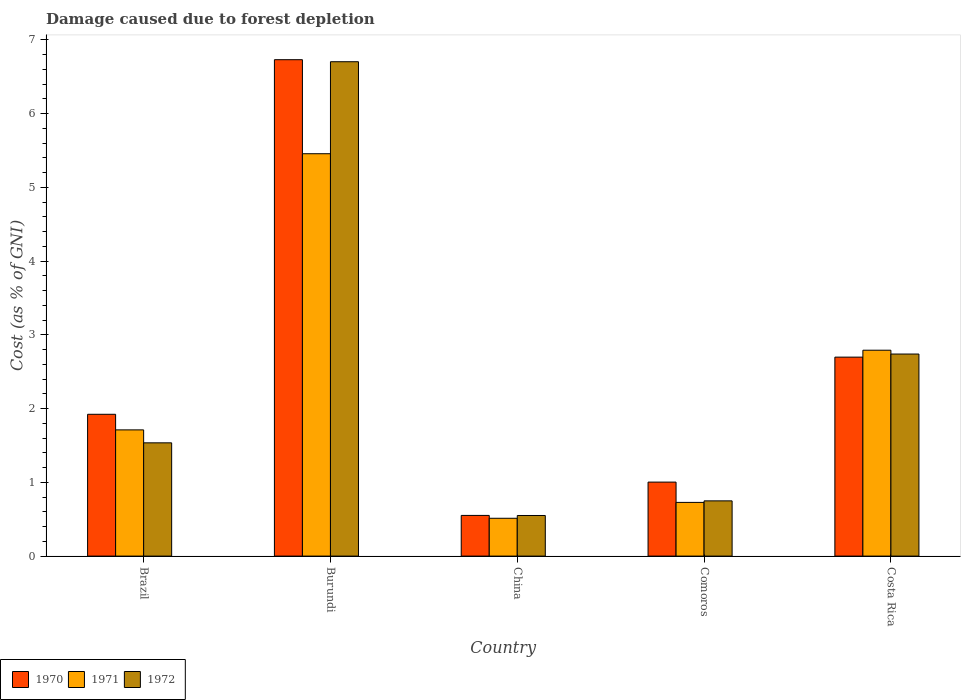How many different coloured bars are there?
Offer a very short reply. 3. Are the number of bars per tick equal to the number of legend labels?
Provide a short and direct response. Yes. Are the number of bars on each tick of the X-axis equal?
Provide a short and direct response. Yes. How many bars are there on the 1st tick from the left?
Make the answer very short. 3. What is the cost of damage caused due to forest depletion in 1972 in Costa Rica?
Your answer should be very brief. 2.74. Across all countries, what is the maximum cost of damage caused due to forest depletion in 1970?
Your answer should be compact. 6.73. Across all countries, what is the minimum cost of damage caused due to forest depletion in 1971?
Your answer should be very brief. 0.51. In which country was the cost of damage caused due to forest depletion in 1971 maximum?
Provide a short and direct response. Burundi. In which country was the cost of damage caused due to forest depletion in 1970 minimum?
Provide a short and direct response. China. What is the total cost of damage caused due to forest depletion in 1971 in the graph?
Your answer should be compact. 11.2. What is the difference between the cost of damage caused due to forest depletion in 1971 in Brazil and that in Burundi?
Keep it short and to the point. -3.75. What is the difference between the cost of damage caused due to forest depletion in 1972 in Burundi and the cost of damage caused due to forest depletion in 1970 in Costa Rica?
Your answer should be very brief. 4.01. What is the average cost of damage caused due to forest depletion in 1970 per country?
Make the answer very short. 2.58. What is the difference between the cost of damage caused due to forest depletion of/in 1970 and cost of damage caused due to forest depletion of/in 1972 in Comoros?
Make the answer very short. 0.25. What is the ratio of the cost of damage caused due to forest depletion in 1971 in Burundi to that in Costa Rica?
Offer a terse response. 1.95. Is the difference between the cost of damage caused due to forest depletion in 1970 in Burundi and Costa Rica greater than the difference between the cost of damage caused due to forest depletion in 1972 in Burundi and Costa Rica?
Provide a short and direct response. Yes. What is the difference between the highest and the second highest cost of damage caused due to forest depletion in 1972?
Your answer should be very brief. -1.2. What is the difference between the highest and the lowest cost of damage caused due to forest depletion in 1972?
Provide a succinct answer. 6.15. Is the sum of the cost of damage caused due to forest depletion in 1970 in Brazil and China greater than the maximum cost of damage caused due to forest depletion in 1972 across all countries?
Give a very brief answer. No. What does the 3rd bar from the left in Costa Rica represents?
Give a very brief answer. 1972. How many bars are there?
Provide a short and direct response. 15. Are all the bars in the graph horizontal?
Your answer should be very brief. No. How many countries are there in the graph?
Ensure brevity in your answer.  5. Are the values on the major ticks of Y-axis written in scientific E-notation?
Provide a short and direct response. No. Does the graph contain grids?
Provide a succinct answer. No. Where does the legend appear in the graph?
Provide a short and direct response. Bottom left. How many legend labels are there?
Offer a very short reply. 3. What is the title of the graph?
Your response must be concise. Damage caused due to forest depletion. Does "1994" appear as one of the legend labels in the graph?
Your answer should be compact. No. What is the label or title of the X-axis?
Your answer should be very brief. Country. What is the label or title of the Y-axis?
Make the answer very short. Cost (as % of GNI). What is the Cost (as % of GNI) in 1970 in Brazil?
Your answer should be compact. 1.92. What is the Cost (as % of GNI) in 1971 in Brazil?
Your answer should be very brief. 1.71. What is the Cost (as % of GNI) in 1972 in Brazil?
Offer a very short reply. 1.54. What is the Cost (as % of GNI) of 1970 in Burundi?
Make the answer very short. 6.73. What is the Cost (as % of GNI) in 1971 in Burundi?
Ensure brevity in your answer.  5.46. What is the Cost (as % of GNI) in 1972 in Burundi?
Provide a succinct answer. 6.71. What is the Cost (as % of GNI) of 1970 in China?
Offer a very short reply. 0.55. What is the Cost (as % of GNI) of 1971 in China?
Ensure brevity in your answer.  0.51. What is the Cost (as % of GNI) in 1972 in China?
Offer a very short reply. 0.55. What is the Cost (as % of GNI) in 1970 in Comoros?
Provide a short and direct response. 1. What is the Cost (as % of GNI) in 1971 in Comoros?
Make the answer very short. 0.73. What is the Cost (as % of GNI) in 1972 in Comoros?
Make the answer very short. 0.75. What is the Cost (as % of GNI) in 1970 in Costa Rica?
Provide a succinct answer. 2.7. What is the Cost (as % of GNI) in 1971 in Costa Rica?
Your answer should be compact. 2.79. What is the Cost (as % of GNI) in 1972 in Costa Rica?
Keep it short and to the point. 2.74. Across all countries, what is the maximum Cost (as % of GNI) of 1970?
Provide a short and direct response. 6.73. Across all countries, what is the maximum Cost (as % of GNI) in 1971?
Offer a terse response. 5.46. Across all countries, what is the maximum Cost (as % of GNI) in 1972?
Make the answer very short. 6.71. Across all countries, what is the minimum Cost (as % of GNI) of 1970?
Your answer should be very brief. 0.55. Across all countries, what is the minimum Cost (as % of GNI) in 1971?
Your answer should be very brief. 0.51. Across all countries, what is the minimum Cost (as % of GNI) in 1972?
Provide a short and direct response. 0.55. What is the total Cost (as % of GNI) of 1970 in the graph?
Provide a short and direct response. 12.91. What is the total Cost (as % of GNI) in 1971 in the graph?
Your answer should be compact. 11.2. What is the total Cost (as % of GNI) in 1972 in the graph?
Ensure brevity in your answer.  12.28. What is the difference between the Cost (as % of GNI) in 1970 in Brazil and that in Burundi?
Your response must be concise. -4.81. What is the difference between the Cost (as % of GNI) of 1971 in Brazil and that in Burundi?
Give a very brief answer. -3.75. What is the difference between the Cost (as % of GNI) of 1972 in Brazil and that in Burundi?
Your response must be concise. -5.17. What is the difference between the Cost (as % of GNI) in 1970 in Brazil and that in China?
Make the answer very short. 1.37. What is the difference between the Cost (as % of GNI) in 1971 in Brazil and that in China?
Offer a very short reply. 1.2. What is the difference between the Cost (as % of GNI) in 1972 in Brazil and that in China?
Provide a succinct answer. 0.99. What is the difference between the Cost (as % of GNI) of 1970 in Brazil and that in Comoros?
Your response must be concise. 0.92. What is the difference between the Cost (as % of GNI) of 1971 in Brazil and that in Comoros?
Ensure brevity in your answer.  0.98. What is the difference between the Cost (as % of GNI) in 1972 in Brazil and that in Comoros?
Give a very brief answer. 0.79. What is the difference between the Cost (as % of GNI) of 1970 in Brazil and that in Costa Rica?
Your answer should be very brief. -0.78. What is the difference between the Cost (as % of GNI) in 1971 in Brazil and that in Costa Rica?
Offer a terse response. -1.08. What is the difference between the Cost (as % of GNI) in 1972 in Brazil and that in Costa Rica?
Your answer should be compact. -1.2. What is the difference between the Cost (as % of GNI) of 1970 in Burundi and that in China?
Keep it short and to the point. 6.18. What is the difference between the Cost (as % of GNI) of 1971 in Burundi and that in China?
Your answer should be compact. 4.94. What is the difference between the Cost (as % of GNI) of 1972 in Burundi and that in China?
Ensure brevity in your answer.  6.15. What is the difference between the Cost (as % of GNI) in 1970 in Burundi and that in Comoros?
Make the answer very short. 5.73. What is the difference between the Cost (as % of GNI) of 1971 in Burundi and that in Comoros?
Keep it short and to the point. 4.73. What is the difference between the Cost (as % of GNI) of 1972 in Burundi and that in Comoros?
Provide a short and direct response. 5.96. What is the difference between the Cost (as % of GNI) in 1970 in Burundi and that in Costa Rica?
Provide a short and direct response. 4.03. What is the difference between the Cost (as % of GNI) of 1971 in Burundi and that in Costa Rica?
Provide a short and direct response. 2.66. What is the difference between the Cost (as % of GNI) in 1972 in Burundi and that in Costa Rica?
Make the answer very short. 3.96. What is the difference between the Cost (as % of GNI) in 1970 in China and that in Comoros?
Provide a short and direct response. -0.45. What is the difference between the Cost (as % of GNI) of 1971 in China and that in Comoros?
Provide a short and direct response. -0.22. What is the difference between the Cost (as % of GNI) of 1972 in China and that in Comoros?
Offer a very short reply. -0.2. What is the difference between the Cost (as % of GNI) of 1970 in China and that in Costa Rica?
Your answer should be compact. -2.15. What is the difference between the Cost (as % of GNI) of 1971 in China and that in Costa Rica?
Make the answer very short. -2.28. What is the difference between the Cost (as % of GNI) in 1972 in China and that in Costa Rica?
Your answer should be compact. -2.19. What is the difference between the Cost (as % of GNI) of 1970 in Comoros and that in Costa Rica?
Keep it short and to the point. -1.7. What is the difference between the Cost (as % of GNI) of 1971 in Comoros and that in Costa Rica?
Offer a very short reply. -2.06. What is the difference between the Cost (as % of GNI) in 1972 in Comoros and that in Costa Rica?
Provide a short and direct response. -1.99. What is the difference between the Cost (as % of GNI) of 1970 in Brazil and the Cost (as % of GNI) of 1971 in Burundi?
Offer a very short reply. -3.53. What is the difference between the Cost (as % of GNI) of 1970 in Brazil and the Cost (as % of GNI) of 1972 in Burundi?
Ensure brevity in your answer.  -4.78. What is the difference between the Cost (as % of GNI) of 1971 in Brazil and the Cost (as % of GNI) of 1972 in Burundi?
Offer a very short reply. -4.99. What is the difference between the Cost (as % of GNI) in 1970 in Brazil and the Cost (as % of GNI) in 1971 in China?
Provide a short and direct response. 1.41. What is the difference between the Cost (as % of GNI) in 1970 in Brazil and the Cost (as % of GNI) in 1972 in China?
Provide a short and direct response. 1.37. What is the difference between the Cost (as % of GNI) of 1971 in Brazil and the Cost (as % of GNI) of 1972 in China?
Provide a short and direct response. 1.16. What is the difference between the Cost (as % of GNI) of 1970 in Brazil and the Cost (as % of GNI) of 1971 in Comoros?
Keep it short and to the point. 1.2. What is the difference between the Cost (as % of GNI) of 1970 in Brazil and the Cost (as % of GNI) of 1972 in Comoros?
Make the answer very short. 1.17. What is the difference between the Cost (as % of GNI) of 1971 in Brazil and the Cost (as % of GNI) of 1972 in Comoros?
Your answer should be very brief. 0.96. What is the difference between the Cost (as % of GNI) of 1970 in Brazil and the Cost (as % of GNI) of 1971 in Costa Rica?
Keep it short and to the point. -0.87. What is the difference between the Cost (as % of GNI) in 1970 in Brazil and the Cost (as % of GNI) in 1972 in Costa Rica?
Provide a short and direct response. -0.82. What is the difference between the Cost (as % of GNI) in 1971 in Brazil and the Cost (as % of GNI) in 1972 in Costa Rica?
Give a very brief answer. -1.03. What is the difference between the Cost (as % of GNI) in 1970 in Burundi and the Cost (as % of GNI) in 1971 in China?
Offer a very short reply. 6.22. What is the difference between the Cost (as % of GNI) of 1970 in Burundi and the Cost (as % of GNI) of 1972 in China?
Your answer should be compact. 6.18. What is the difference between the Cost (as % of GNI) in 1971 in Burundi and the Cost (as % of GNI) in 1972 in China?
Offer a terse response. 4.91. What is the difference between the Cost (as % of GNI) of 1970 in Burundi and the Cost (as % of GNI) of 1971 in Comoros?
Your answer should be compact. 6. What is the difference between the Cost (as % of GNI) in 1970 in Burundi and the Cost (as % of GNI) in 1972 in Comoros?
Provide a short and direct response. 5.98. What is the difference between the Cost (as % of GNI) in 1971 in Burundi and the Cost (as % of GNI) in 1972 in Comoros?
Your response must be concise. 4.71. What is the difference between the Cost (as % of GNI) in 1970 in Burundi and the Cost (as % of GNI) in 1971 in Costa Rica?
Provide a short and direct response. 3.94. What is the difference between the Cost (as % of GNI) in 1970 in Burundi and the Cost (as % of GNI) in 1972 in Costa Rica?
Provide a short and direct response. 3.99. What is the difference between the Cost (as % of GNI) of 1971 in Burundi and the Cost (as % of GNI) of 1972 in Costa Rica?
Provide a succinct answer. 2.72. What is the difference between the Cost (as % of GNI) in 1970 in China and the Cost (as % of GNI) in 1971 in Comoros?
Give a very brief answer. -0.18. What is the difference between the Cost (as % of GNI) of 1970 in China and the Cost (as % of GNI) of 1972 in Comoros?
Your answer should be very brief. -0.2. What is the difference between the Cost (as % of GNI) in 1971 in China and the Cost (as % of GNI) in 1972 in Comoros?
Ensure brevity in your answer.  -0.24. What is the difference between the Cost (as % of GNI) in 1970 in China and the Cost (as % of GNI) in 1971 in Costa Rica?
Keep it short and to the point. -2.24. What is the difference between the Cost (as % of GNI) of 1970 in China and the Cost (as % of GNI) of 1972 in Costa Rica?
Your answer should be very brief. -2.19. What is the difference between the Cost (as % of GNI) of 1971 in China and the Cost (as % of GNI) of 1972 in Costa Rica?
Make the answer very short. -2.23. What is the difference between the Cost (as % of GNI) in 1970 in Comoros and the Cost (as % of GNI) in 1971 in Costa Rica?
Give a very brief answer. -1.79. What is the difference between the Cost (as % of GNI) in 1970 in Comoros and the Cost (as % of GNI) in 1972 in Costa Rica?
Your answer should be compact. -1.74. What is the difference between the Cost (as % of GNI) in 1971 in Comoros and the Cost (as % of GNI) in 1972 in Costa Rica?
Ensure brevity in your answer.  -2.01. What is the average Cost (as % of GNI) of 1970 per country?
Provide a succinct answer. 2.58. What is the average Cost (as % of GNI) of 1971 per country?
Make the answer very short. 2.24. What is the average Cost (as % of GNI) of 1972 per country?
Make the answer very short. 2.46. What is the difference between the Cost (as % of GNI) of 1970 and Cost (as % of GNI) of 1971 in Brazil?
Provide a short and direct response. 0.21. What is the difference between the Cost (as % of GNI) of 1970 and Cost (as % of GNI) of 1972 in Brazil?
Your response must be concise. 0.39. What is the difference between the Cost (as % of GNI) in 1971 and Cost (as % of GNI) in 1972 in Brazil?
Provide a short and direct response. 0.18. What is the difference between the Cost (as % of GNI) in 1970 and Cost (as % of GNI) in 1971 in Burundi?
Make the answer very short. 1.28. What is the difference between the Cost (as % of GNI) in 1970 and Cost (as % of GNI) in 1972 in Burundi?
Give a very brief answer. 0.03. What is the difference between the Cost (as % of GNI) of 1971 and Cost (as % of GNI) of 1972 in Burundi?
Keep it short and to the point. -1.25. What is the difference between the Cost (as % of GNI) in 1970 and Cost (as % of GNI) in 1971 in China?
Provide a succinct answer. 0.04. What is the difference between the Cost (as % of GNI) in 1970 and Cost (as % of GNI) in 1972 in China?
Provide a succinct answer. 0. What is the difference between the Cost (as % of GNI) of 1971 and Cost (as % of GNI) of 1972 in China?
Ensure brevity in your answer.  -0.04. What is the difference between the Cost (as % of GNI) in 1970 and Cost (as % of GNI) in 1971 in Comoros?
Give a very brief answer. 0.28. What is the difference between the Cost (as % of GNI) of 1970 and Cost (as % of GNI) of 1972 in Comoros?
Your answer should be very brief. 0.25. What is the difference between the Cost (as % of GNI) of 1971 and Cost (as % of GNI) of 1972 in Comoros?
Your answer should be compact. -0.02. What is the difference between the Cost (as % of GNI) of 1970 and Cost (as % of GNI) of 1971 in Costa Rica?
Your answer should be very brief. -0.09. What is the difference between the Cost (as % of GNI) in 1970 and Cost (as % of GNI) in 1972 in Costa Rica?
Your answer should be compact. -0.04. What is the difference between the Cost (as % of GNI) in 1971 and Cost (as % of GNI) in 1972 in Costa Rica?
Provide a succinct answer. 0.05. What is the ratio of the Cost (as % of GNI) in 1970 in Brazil to that in Burundi?
Provide a short and direct response. 0.29. What is the ratio of the Cost (as % of GNI) of 1971 in Brazil to that in Burundi?
Give a very brief answer. 0.31. What is the ratio of the Cost (as % of GNI) in 1972 in Brazil to that in Burundi?
Give a very brief answer. 0.23. What is the ratio of the Cost (as % of GNI) in 1970 in Brazil to that in China?
Make the answer very short. 3.49. What is the ratio of the Cost (as % of GNI) of 1971 in Brazil to that in China?
Offer a terse response. 3.34. What is the ratio of the Cost (as % of GNI) of 1972 in Brazil to that in China?
Keep it short and to the point. 2.79. What is the ratio of the Cost (as % of GNI) of 1970 in Brazil to that in Comoros?
Make the answer very short. 1.92. What is the ratio of the Cost (as % of GNI) of 1971 in Brazil to that in Comoros?
Your answer should be compact. 2.35. What is the ratio of the Cost (as % of GNI) of 1972 in Brazil to that in Comoros?
Your answer should be compact. 2.05. What is the ratio of the Cost (as % of GNI) of 1970 in Brazil to that in Costa Rica?
Offer a very short reply. 0.71. What is the ratio of the Cost (as % of GNI) of 1971 in Brazil to that in Costa Rica?
Provide a succinct answer. 0.61. What is the ratio of the Cost (as % of GNI) of 1972 in Brazil to that in Costa Rica?
Your response must be concise. 0.56. What is the ratio of the Cost (as % of GNI) of 1970 in Burundi to that in China?
Keep it short and to the point. 12.2. What is the ratio of the Cost (as % of GNI) in 1971 in Burundi to that in China?
Your answer should be very brief. 10.64. What is the ratio of the Cost (as % of GNI) of 1972 in Burundi to that in China?
Provide a succinct answer. 12.17. What is the ratio of the Cost (as % of GNI) of 1970 in Burundi to that in Comoros?
Offer a very short reply. 6.71. What is the ratio of the Cost (as % of GNI) of 1971 in Burundi to that in Comoros?
Offer a very short reply. 7.49. What is the ratio of the Cost (as % of GNI) in 1972 in Burundi to that in Comoros?
Give a very brief answer. 8.95. What is the ratio of the Cost (as % of GNI) of 1970 in Burundi to that in Costa Rica?
Give a very brief answer. 2.49. What is the ratio of the Cost (as % of GNI) of 1971 in Burundi to that in Costa Rica?
Give a very brief answer. 1.95. What is the ratio of the Cost (as % of GNI) of 1972 in Burundi to that in Costa Rica?
Ensure brevity in your answer.  2.45. What is the ratio of the Cost (as % of GNI) of 1970 in China to that in Comoros?
Offer a terse response. 0.55. What is the ratio of the Cost (as % of GNI) in 1971 in China to that in Comoros?
Provide a short and direct response. 0.7. What is the ratio of the Cost (as % of GNI) in 1972 in China to that in Comoros?
Ensure brevity in your answer.  0.74. What is the ratio of the Cost (as % of GNI) of 1970 in China to that in Costa Rica?
Your answer should be compact. 0.2. What is the ratio of the Cost (as % of GNI) of 1971 in China to that in Costa Rica?
Offer a very short reply. 0.18. What is the ratio of the Cost (as % of GNI) in 1972 in China to that in Costa Rica?
Your answer should be compact. 0.2. What is the ratio of the Cost (as % of GNI) in 1970 in Comoros to that in Costa Rica?
Your response must be concise. 0.37. What is the ratio of the Cost (as % of GNI) of 1971 in Comoros to that in Costa Rica?
Ensure brevity in your answer.  0.26. What is the ratio of the Cost (as % of GNI) in 1972 in Comoros to that in Costa Rica?
Offer a terse response. 0.27. What is the difference between the highest and the second highest Cost (as % of GNI) in 1970?
Offer a terse response. 4.03. What is the difference between the highest and the second highest Cost (as % of GNI) in 1971?
Your answer should be compact. 2.66. What is the difference between the highest and the second highest Cost (as % of GNI) of 1972?
Give a very brief answer. 3.96. What is the difference between the highest and the lowest Cost (as % of GNI) in 1970?
Make the answer very short. 6.18. What is the difference between the highest and the lowest Cost (as % of GNI) in 1971?
Ensure brevity in your answer.  4.94. What is the difference between the highest and the lowest Cost (as % of GNI) of 1972?
Your response must be concise. 6.15. 